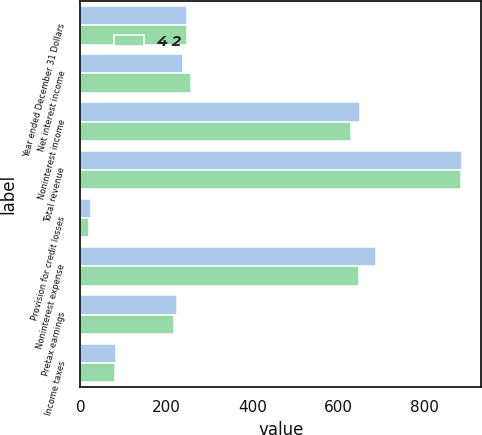<chart> <loc_0><loc_0><loc_500><loc_500><stacked_bar_chart><ecel><fcel>Year ended December 31 Dollars<fcel>Net interest income<fcel>Noninterest income<fcel>Total revenue<fcel>Provision for credit losses<fcel>Noninterest expense<fcel>Pretax earnings<fcel>Income taxes<nl><fcel>nan<fcel>247<fcel>238<fcel>649<fcel>887<fcel>24<fcel>687<fcel>224<fcel>83<nl><fcel>4 2<fcel>247<fcel>256<fcel>628<fcel>884<fcel>20<fcel>647<fcel>217<fcel>80<nl></chart> 